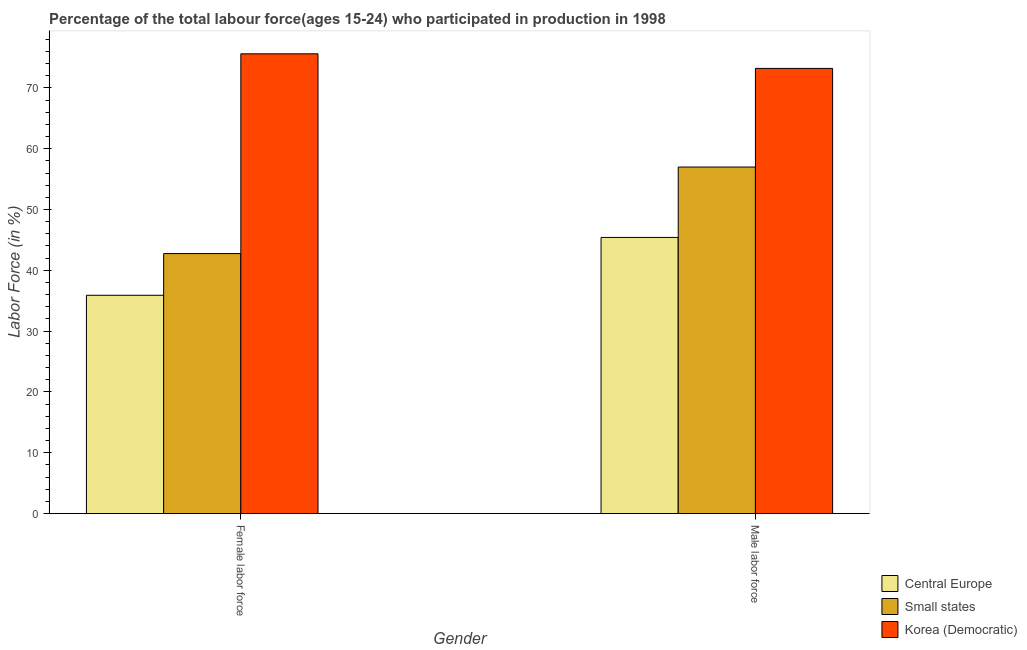How many different coloured bars are there?
Make the answer very short. 3. Are the number of bars per tick equal to the number of legend labels?
Keep it short and to the point. Yes. How many bars are there on the 2nd tick from the left?
Offer a terse response. 3. What is the label of the 1st group of bars from the left?
Offer a terse response. Female labor force. What is the percentage of male labour force in Small states?
Give a very brief answer. 56.98. Across all countries, what is the maximum percentage of female labor force?
Your response must be concise. 75.6. Across all countries, what is the minimum percentage of male labour force?
Provide a short and direct response. 45.41. In which country was the percentage of male labour force maximum?
Ensure brevity in your answer.  Korea (Democratic). In which country was the percentage of female labor force minimum?
Ensure brevity in your answer.  Central Europe. What is the total percentage of female labor force in the graph?
Provide a short and direct response. 154.25. What is the difference between the percentage of female labor force in Small states and that in Central Europe?
Make the answer very short. 6.86. What is the difference between the percentage of female labor force in Central Europe and the percentage of male labour force in Small states?
Keep it short and to the point. -21.09. What is the average percentage of male labour force per country?
Offer a terse response. 58.53. What is the difference between the percentage of female labor force and percentage of male labour force in Small states?
Provide a succinct answer. -14.23. In how many countries, is the percentage of female labor force greater than 16 %?
Your answer should be very brief. 3. What is the ratio of the percentage of male labour force in Small states to that in Korea (Democratic)?
Make the answer very short. 0.78. In how many countries, is the percentage of female labor force greater than the average percentage of female labor force taken over all countries?
Your answer should be compact. 1. What does the 1st bar from the left in Male labor force represents?
Your answer should be compact. Central Europe. What does the 3rd bar from the right in Male labor force represents?
Give a very brief answer. Central Europe. How many bars are there?
Your answer should be very brief. 6. Are all the bars in the graph horizontal?
Provide a succinct answer. No. Are the values on the major ticks of Y-axis written in scientific E-notation?
Your answer should be compact. No. Does the graph contain any zero values?
Offer a very short reply. No. Does the graph contain grids?
Ensure brevity in your answer.  No. Where does the legend appear in the graph?
Provide a short and direct response. Bottom right. How many legend labels are there?
Give a very brief answer. 3. What is the title of the graph?
Your answer should be very brief. Percentage of the total labour force(ages 15-24) who participated in production in 1998. What is the label or title of the Y-axis?
Your response must be concise. Labor Force (in %). What is the Labor Force (in %) of Central Europe in Female labor force?
Offer a terse response. 35.89. What is the Labor Force (in %) of Small states in Female labor force?
Provide a short and direct response. 42.76. What is the Labor Force (in %) in Korea (Democratic) in Female labor force?
Provide a succinct answer. 75.6. What is the Labor Force (in %) in Central Europe in Male labor force?
Give a very brief answer. 45.41. What is the Labor Force (in %) of Small states in Male labor force?
Your response must be concise. 56.98. What is the Labor Force (in %) of Korea (Democratic) in Male labor force?
Your answer should be very brief. 73.2. Across all Gender, what is the maximum Labor Force (in %) in Central Europe?
Your answer should be very brief. 45.41. Across all Gender, what is the maximum Labor Force (in %) in Small states?
Offer a terse response. 56.98. Across all Gender, what is the maximum Labor Force (in %) in Korea (Democratic)?
Your answer should be compact. 75.6. Across all Gender, what is the minimum Labor Force (in %) of Central Europe?
Give a very brief answer. 35.89. Across all Gender, what is the minimum Labor Force (in %) in Small states?
Provide a succinct answer. 42.76. Across all Gender, what is the minimum Labor Force (in %) in Korea (Democratic)?
Make the answer very short. 73.2. What is the total Labor Force (in %) of Central Europe in the graph?
Your answer should be very brief. 81.3. What is the total Labor Force (in %) of Small states in the graph?
Your response must be concise. 99.74. What is the total Labor Force (in %) in Korea (Democratic) in the graph?
Your answer should be compact. 148.8. What is the difference between the Labor Force (in %) in Central Europe in Female labor force and that in Male labor force?
Your response must be concise. -9.51. What is the difference between the Labor Force (in %) of Small states in Female labor force and that in Male labor force?
Your response must be concise. -14.23. What is the difference between the Labor Force (in %) in Korea (Democratic) in Female labor force and that in Male labor force?
Offer a very short reply. 2.4. What is the difference between the Labor Force (in %) of Central Europe in Female labor force and the Labor Force (in %) of Small states in Male labor force?
Ensure brevity in your answer.  -21.09. What is the difference between the Labor Force (in %) in Central Europe in Female labor force and the Labor Force (in %) in Korea (Democratic) in Male labor force?
Offer a very short reply. -37.31. What is the difference between the Labor Force (in %) of Small states in Female labor force and the Labor Force (in %) of Korea (Democratic) in Male labor force?
Give a very brief answer. -30.44. What is the average Labor Force (in %) of Central Europe per Gender?
Give a very brief answer. 40.65. What is the average Labor Force (in %) in Small states per Gender?
Offer a very short reply. 49.87. What is the average Labor Force (in %) of Korea (Democratic) per Gender?
Provide a succinct answer. 74.4. What is the difference between the Labor Force (in %) of Central Europe and Labor Force (in %) of Small states in Female labor force?
Provide a succinct answer. -6.86. What is the difference between the Labor Force (in %) of Central Europe and Labor Force (in %) of Korea (Democratic) in Female labor force?
Provide a succinct answer. -39.71. What is the difference between the Labor Force (in %) in Small states and Labor Force (in %) in Korea (Democratic) in Female labor force?
Offer a terse response. -32.84. What is the difference between the Labor Force (in %) of Central Europe and Labor Force (in %) of Small states in Male labor force?
Your answer should be very brief. -11.58. What is the difference between the Labor Force (in %) in Central Europe and Labor Force (in %) in Korea (Democratic) in Male labor force?
Make the answer very short. -27.79. What is the difference between the Labor Force (in %) in Small states and Labor Force (in %) in Korea (Democratic) in Male labor force?
Keep it short and to the point. -16.22. What is the ratio of the Labor Force (in %) of Central Europe in Female labor force to that in Male labor force?
Make the answer very short. 0.79. What is the ratio of the Labor Force (in %) of Small states in Female labor force to that in Male labor force?
Ensure brevity in your answer.  0.75. What is the ratio of the Labor Force (in %) of Korea (Democratic) in Female labor force to that in Male labor force?
Give a very brief answer. 1.03. What is the difference between the highest and the second highest Labor Force (in %) in Central Europe?
Your answer should be compact. 9.51. What is the difference between the highest and the second highest Labor Force (in %) in Small states?
Your response must be concise. 14.23. What is the difference between the highest and the lowest Labor Force (in %) of Central Europe?
Offer a very short reply. 9.51. What is the difference between the highest and the lowest Labor Force (in %) in Small states?
Offer a terse response. 14.23. 